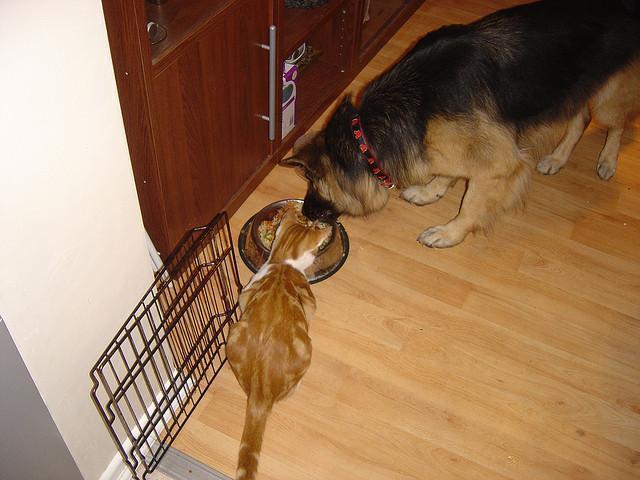How many bottles is the lady touching?
Give a very brief answer. 0. 